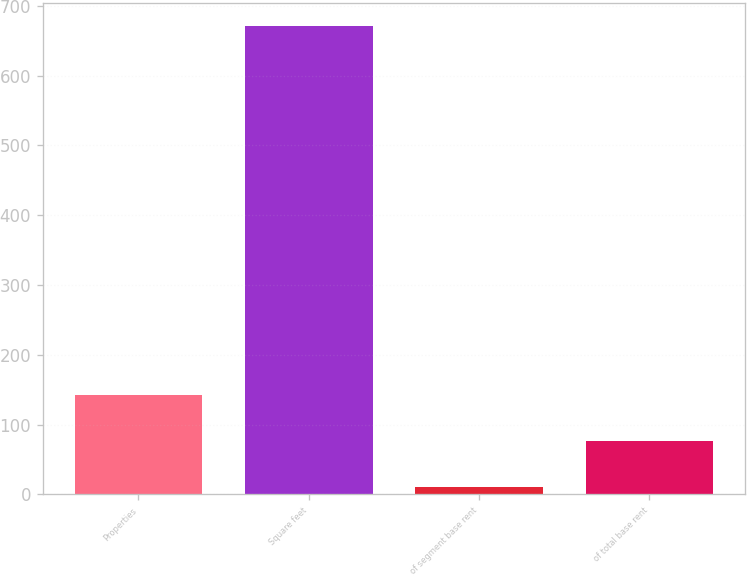<chart> <loc_0><loc_0><loc_500><loc_500><bar_chart><fcel>Properties<fcel>Square feet<fcel>of segment base rent<fcel>of total base rent<nl><fcel>143<fcel>671<fcel>11<fcel>77<nl></chart> 